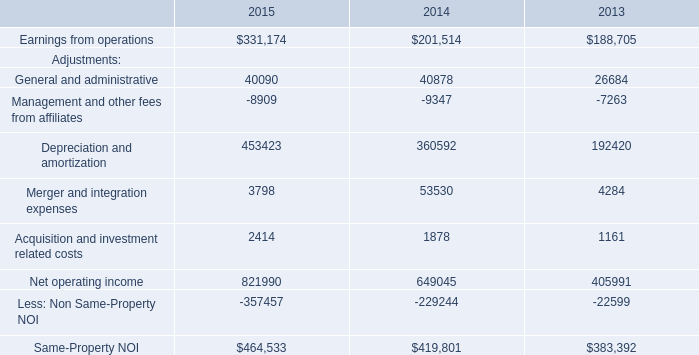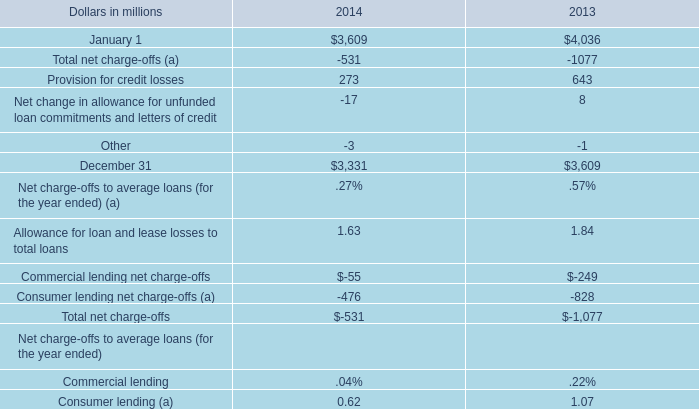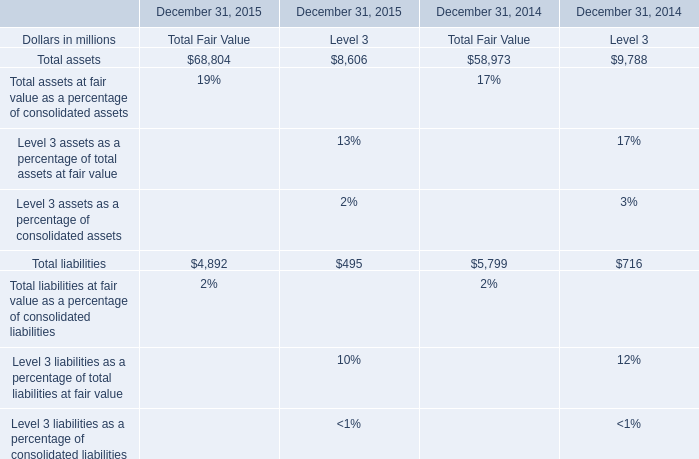What's the sum of Earnings from operations of 2014, and December 31 of 2014 ? 
Computations: (201514.0 + 3331.0)
Answer: 204845.0. 